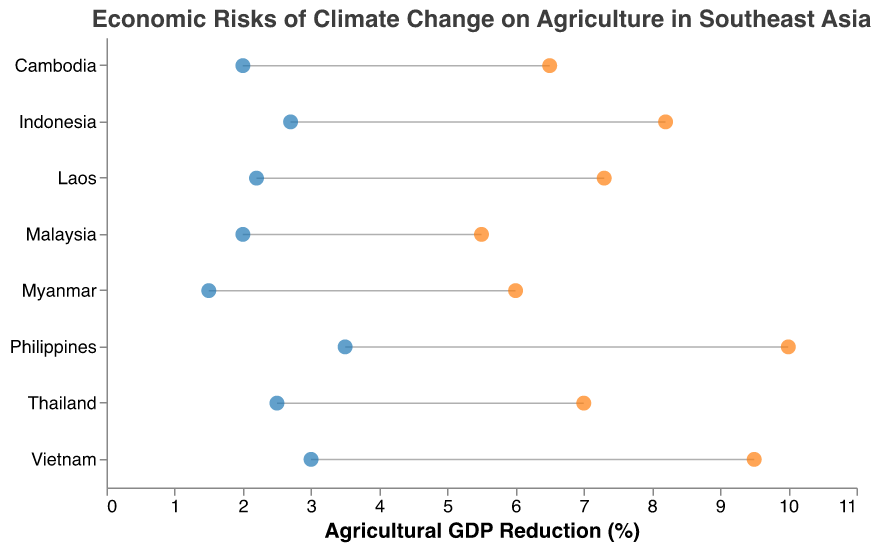How many countries are displayed in the figure? The figure shows a list of countries on the y-axis. Counting the number of country names listed will give the total number of countries displayed.
Answer: 8 What is the title of the figure? The title is typically displayed at the top of the figure in a larger font size, which summarizes the content being depicted.
Answer: Economic Risks of Climate Change on Agriculture in Southeast Asia Which country has the highest potential reduction in agricultural GDP? Locate the country with the highest point on the x-axis under "High Impact." This identifies the country with the maximum potential reduction in agricultural GDP.
Answer: Philippines What is the range of agricultural GDP reduction for Malaysia? For Malaysia, find both the low and high impacts on the x-axis to determine the range. Subtract the low value from the high value.
Answer: 3.5% Which sub-region has a greater potential maximum impact, Mainland Southeast Asia or Maritime Southeast Asia? Compare the highest "High Impact" values of countries within Mainland Southeast Asia and Maritime Southeast Asia sub-regions. The region with the higher maximum value has a greater potential impact.
Answer: Maritime Southeast Asia How does the high impact of Vietnam compare to that of Thailand? Look at the "High Impact" points for both Vietnam and Thailand. Compare their positions on the x-axis to see which is higher.
Answer: Vietnam is higher What is the average high impact for Mainland Southeast Asia countries? Sum the "High Impact" values for the Mainland Southeast Asia countries (Thailand, Vietnam, Myanmar, Cambodia, Laos) and divide by the number of such countries to find the average.
Answer: 7.26% Which country has the smallest range of agricultural GDP reduction? Calculate the ranges for each country by subtracting the "Low Impact" from the "High Impact." The country with the smallest difference is the one with the smallest range.
Answer: Malaysia What is the difference in low impact values between Thailand and the Philippines? Subtract the "Low Impact" value of Thailand from the "Low Impact" value of the Philippines to find the difference.
Answer: 1.0% Which country in Mainland Southeast Asia has the lowest potential reduction in agricultural GDP? Locate the country within Mainland Southeast Asia with the lowest "High Impact" value.
Answer: Myanmar 